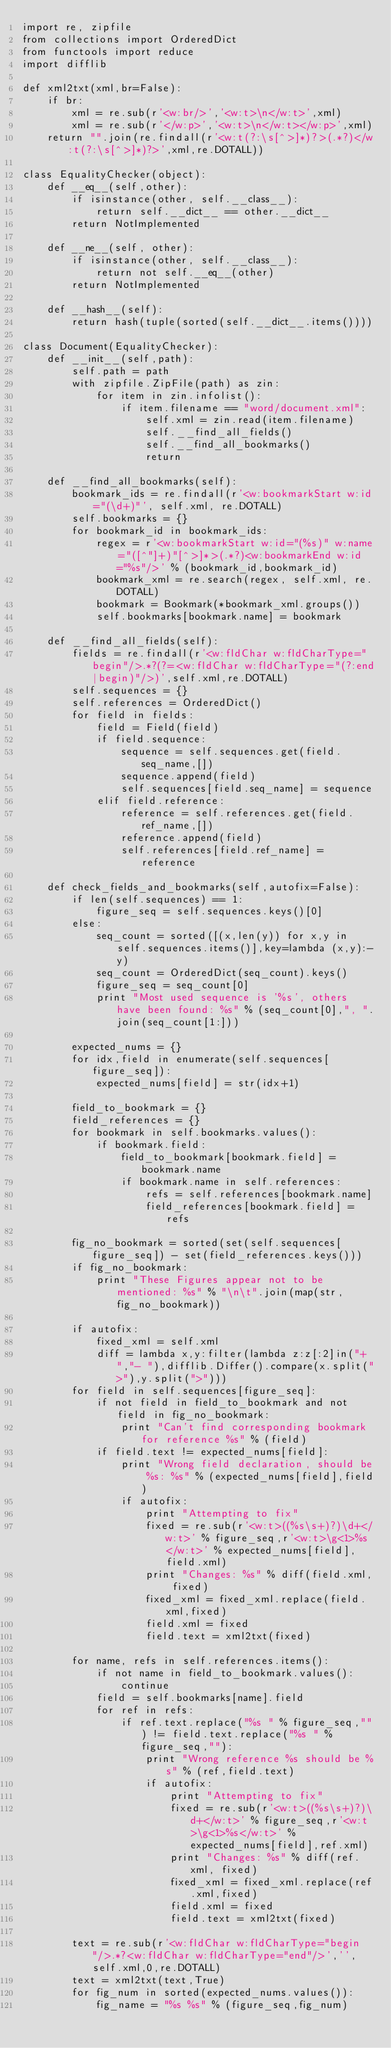Convert code to text. <code><loc_0><loc_0><loc_500><loc_500><_Python_>import re, zipfile
from collections import OrderedDict
from functools import reduce
import difflib

def xml2txt(xml,br=False):
	if br:
		xml = re.sub(r'<w:br/>','<w:t>\n</w:t>',xml)
		xml = re.sub(r'</w:p>','<w:t>\n</w:t></w:p>',xml)
	return "".join(re.findall(r'<w:t(?:\s[^>]*)?>(.*?)</w:t(?:\s[^>]*)?>',xml,re.DOTALL))

class EqualityChecker(object):
	def __eq__(self,other):
		if isinstance(other, self.__class__):
			return self.__dict__ == other.__dict__
		return NotImplemented

	def __ne__(self, other):
		if isinstance(other, self.__class__):
			return not self.__eq__(other)
		return NotImplemented

	def __hash__(self):
		return hash(tuple(sorted(self.__dict__.items())))

class Document(EqualityChecker):
	def __init__(self,path):
		self.path = path
		with zipfile.ZipFile(path) as zin:
			for item in zin.infolist():
				if item.filename == "word/document.xml":
					self.xml = zin.read(item.filename)
					self.__find_all_fields()
					self.__find_all_bookmarks()
					return

	def __find_all_bookmarks(self):
		bookmark_ids = re.findall(r'<w:bookmarkStart w:id="(\d+)"', self.xml, re.DOTALL)
		self.bookmarks = {}
		for bookmark_id in bookmark_ids:
			regex = r'<w:bookmarkStart w:id="(%s)" w:name="([^"]+)"[^>]*>(.*?)<w:bookmarkEnd w:id="%s"/>' % (bookmark_id,bookmark_id)
			bookmark_xml = re.search(regex, self.xml, re.DOTALL)
			bookmark = Bookmark(*bookmark_xml.groups())
			self.bookmarks[bookmark.name] = bookmark

	def __find_all_fields(self):
		fields = re.findall(r'<w:fldChar w:fldCharType="begin"/>.*?(?=<w:fldChar w:fldCharType="(?:end|begin)"/>)',self.xml,re.DOTALL)
		self.sequences = {}
		self.references = OrderedDict()
		for field in fields:
			field = Field(field)
			if field.sequence:
				sequence = self.sequences.get(field.seq_name,[])
				sequence.append(field)
				self.sequences[field.seq_name] = sequence
			elif field.reference:
				reference = self.references.get(field.ref_name,[])
				reference.append(field)
				self.references[field.ref_name] = reference

	def check_fields_and_bookmarks(self,autofix=False):
		if len(self.sequences) == 1:
			figure_seq = self.sequences.keys()[0]
		else:
			seq_count = sorted([(x,len(y)) for x,y in self.sequences.items()],key=lambda (x,y):-y)
			seq_count = OrderedDict(seq_count).keys()
			figure_seq = seq_count[0]
			print "Most used sequence is '%s', others have been found: %s" % (seq_count[0],", ".join(seq_count[1:]))

		expected_nums = {}
		for idx,field in enumerate(self.sequences[figure_seq]):
			expected_nums[field] = str(idx+1)

		field_to_bookmark = {}
		field_references = {}
		for bookmark in self.bookmarks.values():
			if bookmark.field:
				field_to_bookmark[bookmark.field] = bookmark.name
				if bookmark.name in self.references:
					refs = self.references[bookmark.name]
					field_references[bookmark.field] = refs

		fig_no_bookmark = sorted(set(self.sequences[figure_seq]) - set(field_references.keys()))
		if fig_no_bookmark:
			print "These Figures appear not to be mentioned: %s" % "\n\t".join(map(str,fig_no_bookmark))

		if autofix:
			fixed_xml = self.xml
			diff = lambda x,y:filter(lambda z:z[:2]in("+ ","- "),difflib.Differ().compare(x.split(">"),y.split(">")))
		for field in self.sequences[figure_seq]:
			if not field in field_to_bookmark and not field in fig_no_bookmark:
				print "Can't find corresponding bookmark for reference %s" % (field)
			if field.text != expected_nums[field]:
				print "Wrong field declaration, should be %s: %s" % (expected_nums[field],field)
				if autofix:
					print "Attempting to fix"
					fixed = re.sub(r'<w:t>((%s\s+)?)\d+</w:t>' % figure_seq,r'<w:t>\g<1>%s</w:t>' % expected_nums[field],field.xml)
					print "Changes: %s" % diff(field.xml, fixed)
					fixed_xml = fixed_xml.replace(field.xml,fixed)
					field.xml = fixed
					field.text = xml2txt(fixed)

		for name, refs in self.references.items():
			if not name in field_to_bookmark.values():
				continue
			field = self.bookmarks[name].field
			for ref in refs:
				if ref.text.replace("%s " % figure_seq,"") != field.text.replace("%s " % figure_seq,""):
					print "Wrong reference %s should be %s" % (ref,field.text)
					if autofix:
						print "Attempting to fix"
						fixed = re.sub(r'<w:t>((%s\s+)?)\d+</w:t>' % figure_seq,r'<w:t>\g<1>%s</w:t>' % expected_nums[field],ref.xml)
						print "Changes: %s" % diff(ref.xml, fixed)
						fixed_xml = fixed_xml.replace(ref.xml,fixed)
						field.xml = fixed
						field.text = xml2txt(fixed)

		text = re.sub(r'<w:fldChar w:fldCharType="begin"/>.*?<w:fldChar w:fldCharType="end"/>','',self.xml,0,re.DOTALL)
		text = xml2txt(text,True)
		for fig_num in sorted(expected_nums.values()):
			fig_name = "%s %s" % (figure_seq,fig_num)</code> 